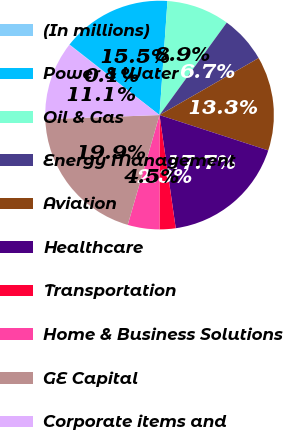Convert chart to OTSL. <chart><loc_0><loc_0><loc_500><loc_500><pie_chart><fcel>(In millions)<fcel>Power & Water<fcel>Oil & Gas<fcel>Energy Management<fcel>Aviation<fcel>Healthcare<fcel>Transportation<fcel>Home & Business Solutions<fcel>GE Capital<fcel>Corporate items and<nl><fcel>0.06%<fcel>15.52%<fcel>8.9%<fcel>6.69%<fcel>13.31%<fcel>17.73%<fcel>2.27%<fcel>4.48%<fcel>19.94%<fcel>11.1%<nl></chart> 